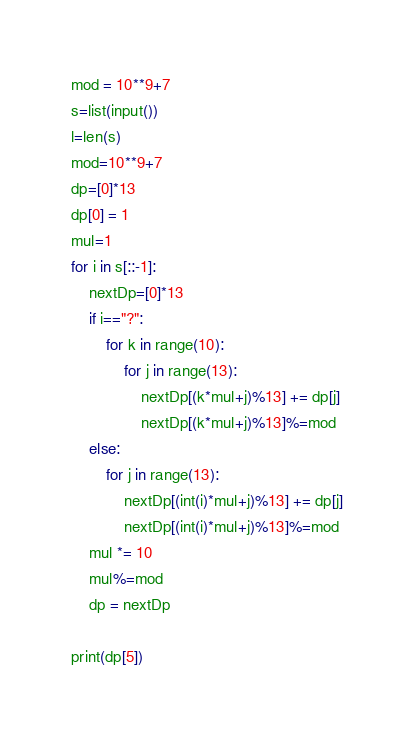Convert code to text. <code><loc_0><loc_0><loc_500><loc_500><_Python_>mod = 10**9+7
s=list(input())
l=len(s)
mod=10**9+7
dp=[0]*13
dp[0] = 1
mul=1
for i in s[::-1]:
    nextDp=[0]*13
    if i=="?":
        for k in range(10):
            for j in range(13):
                nextDp[(k*mul+j)%13] += dp[j]
                nextDp[(k*mul+j)%13]%=mod
    else:
        for j in range(13):
            nextDp[(int(i)*mul+j)%13] += dp[j]
            nextDp[(int(i)*mul+j)%13]%=mod
    mul *= 10
    mul%=mod
    dp = nextDp

print(dp[5])</code> 